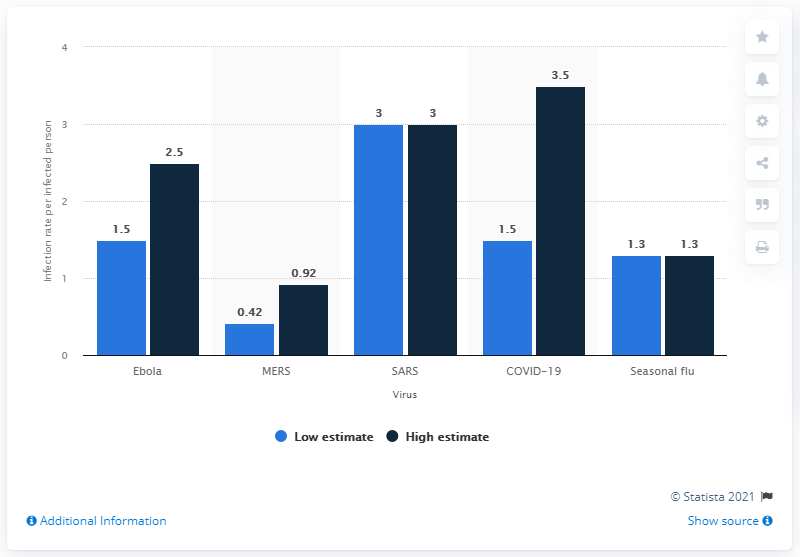Draw attention to some important aspects in this diagram. The seasonal flu's infection rate in March 2020 was 1.3. The outbreak of COVID-19 has the largest discrepancy between the lowest and highest estimates among all global outbreaks. The MERS outbreak has the lowest infection rates among the outbreaks being considered. 